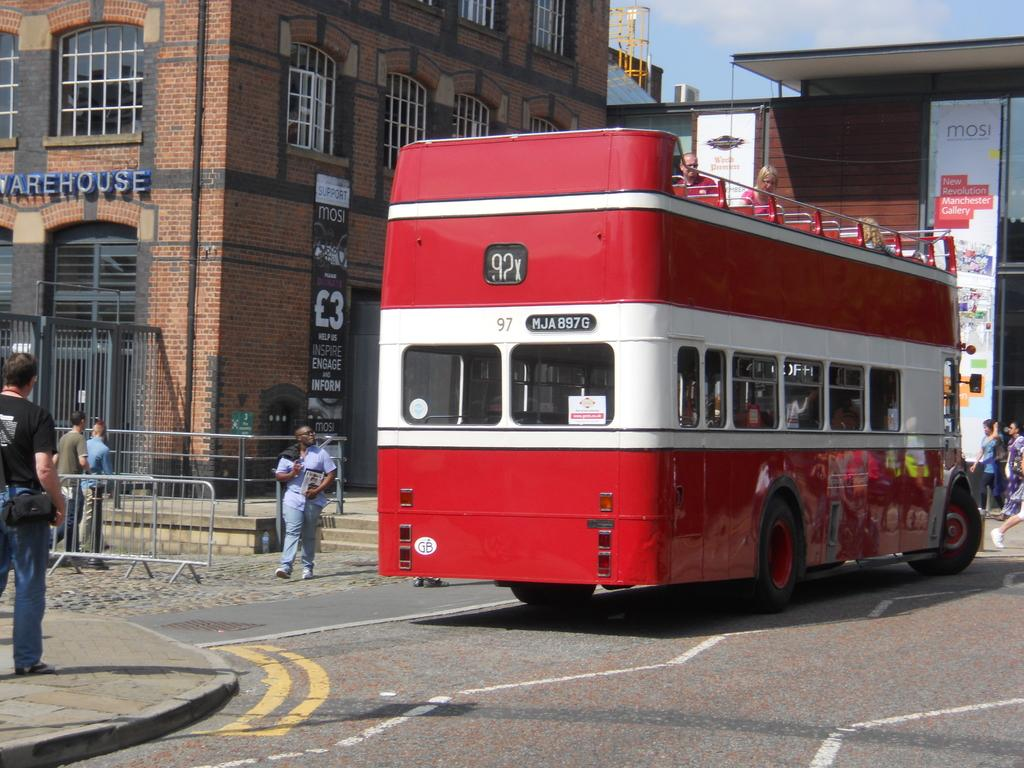Provide a one-sentence caption for the provided image. A red open topped bus with the number 92 on the back. 